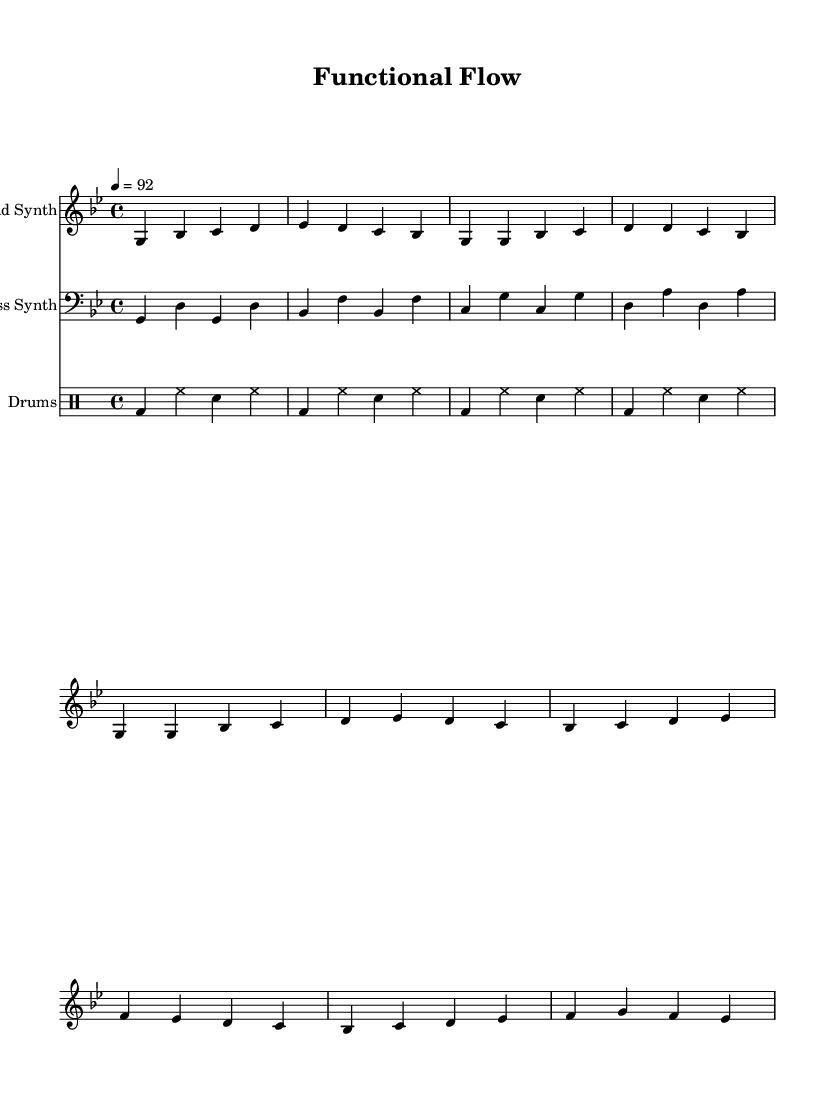What is the key signature of this music? The key signature is indicated at the beginning of the score. In this case, it shows B-flat and E-flat, denoting the key of G minor.
Answer: G minor What is the time signature? The time signature appears at the beginning of the score and is shown as 4/4, meaning there are four beats per measure and the quarter note gets one beat.
Answer: 4/4 What is the tempo marking? The tempo marking is located at the beginning of the score and indicates the speed of the piece, noted as 92 beats per minute, which suggests a moderately fast pace.
Answer: 92 How many measures are there in the verse? The verse is indicated by the music notation under the lead synth staff. By counting the individual segments of music notation in the verse section, we see there are four measures.
Answer: 4 What type of musical form does this rap use? The structure is evident through the organization of verses and choruses within the score. In this case, it shows a repeated verse and chorus pattern, which is typical for rap.
Answer: Verse-Chorus What is the primary theme of the lyrics? The lyrics reveal the main idea focused on the benefits and features of functional programming, emphasizing purity and immutability. By reading through the lyrics section, it is clear that the theme centers around functional programming concepts.
Answer: Functional programming What instruments are used in this piece? The score specifies several instruments: the lead synth, bass synth, and drums. Each instrument is represented by a separate staff line, detailing how they are played together in the piece.
Answer: Lead synth, bass synth, drums 